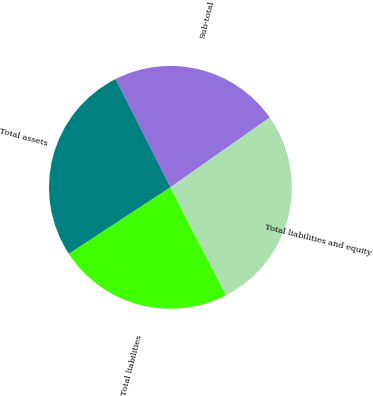Convert chart. <chart><loc_0><loc_0><loc_500><loc_500><pie_chart><fcel>Sub-total<fcel>Total assets<fcel>Total liabilities<fcel>Total liabilities and equity<nl><fcel>22.72%<fcel>26.77%<fcel>23.35%<fcel>27.17%<nl></chart> 